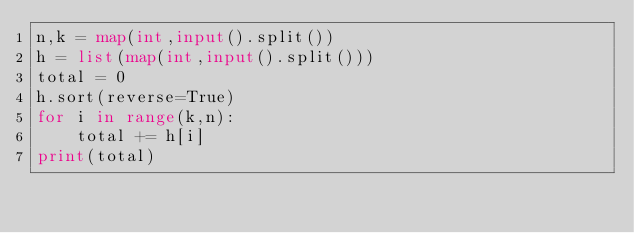<code> <loc_0><loc_0><loc_500><loc_500><_Python_>n,k = map(int,input().split())
h = list(map(int,input().split()))
total = 0
h.sort(reverse=True)
for i in range(k,n):
    total += h[i]
print(total)</code> 